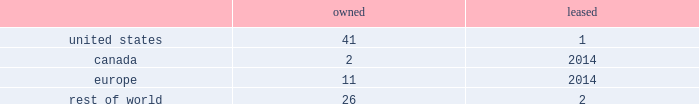While we have remediated the previously-identified material weakness in our internal control over financial reporting , we may identify other material weaknesses in the future .
In november 2017 , we restated our consolidated financial statements for the quarters ended april 1 , 2017 and july 1 , 2017 in order to correctly classify cash receipts from the payments on sold receivables ( which are cash receipts on the underlying trade receivables that have already been securitized ) to cash provided by investing activities ( from cash provided by operating activities ) within our condensed consolidated statements of cash flows .
In connection with these restatements , management identified a material weakness in our internal control over financial reporting related to the misapplication of accounting standards update 2016-15 .
Specifically , we did not maintain effective controls over the adoption of new accounting standards , including communication with the appropriate individuals in coming to our conclusions on the application of new accounting standards .
As a result of this material weakness , our management concluded that we did not maintain effective internal control over financial reporting as of april 1 , 2017 and july 1 , 2017 .
While we have remediated the material weakness and our management has determined that our disclosure controls and procedures were effective as of december 30 , 2017 , there can be no assurance that our controls will remain adequate .
The effectiveness of our internal control over financial reporting is subject to various inherent limitations , including judgments used in decision-making , the nature and complexity of the transactions we undertake , assumptions about the likelihood of future events , the soundness of our systems , cost limitations , and other limitations .
If other material weaknesses or significant deficiencies in our internal control are discovered or occur in the future or we otherwise must restate our financial statements , it could materially and adversely affect our business and results of operations or financial condition , restrict our ability to access the capital markets , require us to expend significant resources to correct the weaknesses or deficiencies , subject us to fines , penalties , investigations or judgments , harm our reputation , or otherwise cause a decline in investor confidence .
Item 1b .
Unresolved staff comments .
Item 2 .
Properties .
Our corporate co-headquarters are located in pittsburgh , pennsylvania and chicago , illinois .
Our co-headquarters are leased and house certain executive offices , our u.s .
Business units , and our administrative , finance , legal , and human resource functions .
We maintain additional owned and leased offices throughout the regions in which we operate .
We manufacture our products in our network of manufacturing and processing facilities located throughout the world .
As of december 30 , 2017 , we operated 83 manufacturing and processing facilities .
We own 80 and lease three of these facilities .
Our manufacturing and processing facilities count by segment as of december 30 , 2017 was: .
We maintain all of our manufacturing and processing facilities in good condition and believe they are suitable and are adequate for our present needs .
We also enter into co-manufacturing arrangements with third parties if we determine it is advantageous to outsource the production of any of our products .
Item 3 .
Legal proceedings .
We are routinely involved in legal proceedings , claims , and governmental inquiries , inspections or investigations ( 201clegal matters 201d ) arising in the ordinary course of our business .
While we cannot predict with certainty the results of legal matters in which we are currently involved or may in the future be involved , we do not expect that the ultimate costs to resolve any of the legal matters that are currently pending will have a material adverse effect on our financial condition or results of operations .
Item 4 .
Mine safety disclosures .
Not applicable. .
What percent of owned facilities are in the us? 
Computations: (41 / 80)
Answer: 0.5125. 